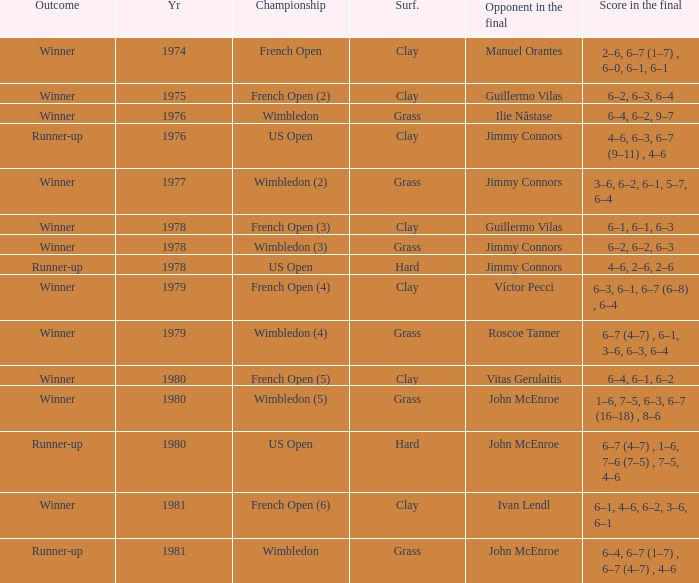What is every score in the final for opponent in final John Mcenroe at US Open? 6–7 (4–7) , 1–6, 7–6 (7–5) , 7–5, 4–6. 